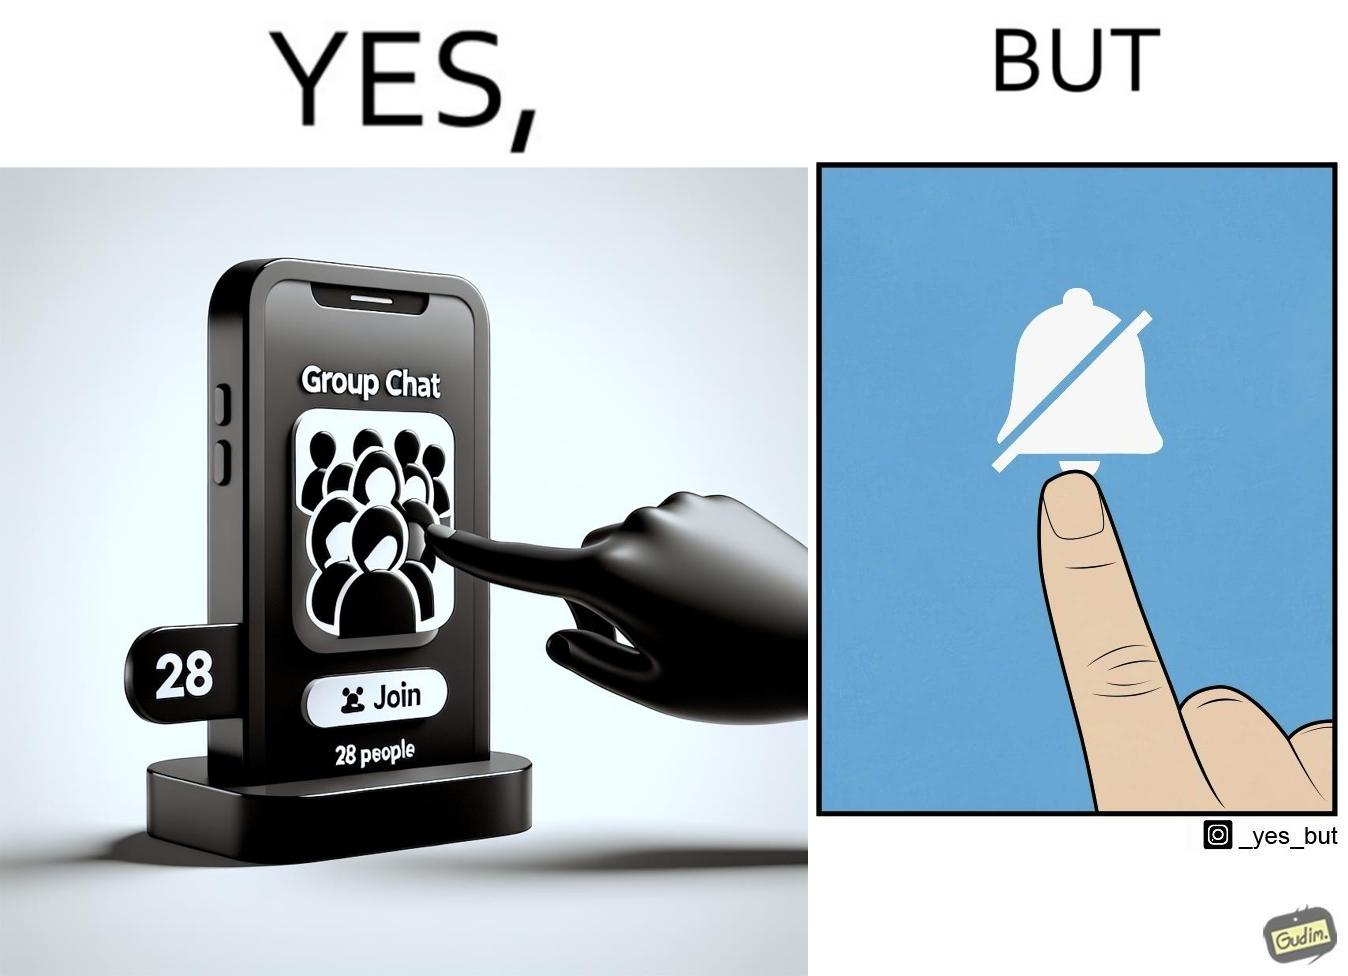Describe what you see in the left and right parts of this image. In the left part of the image: Close-up of phone screen, that has the phrase "Group Chat" on it, and the phrase "28 People" right below it. It  has button labeled "JOIN", and a person's finger is seen clicking the button. In the right part of the image: A touch screen with a "mute notifications" button symbol ( a bell icon that is struck through).  A person's finger is seen clicking the button. 